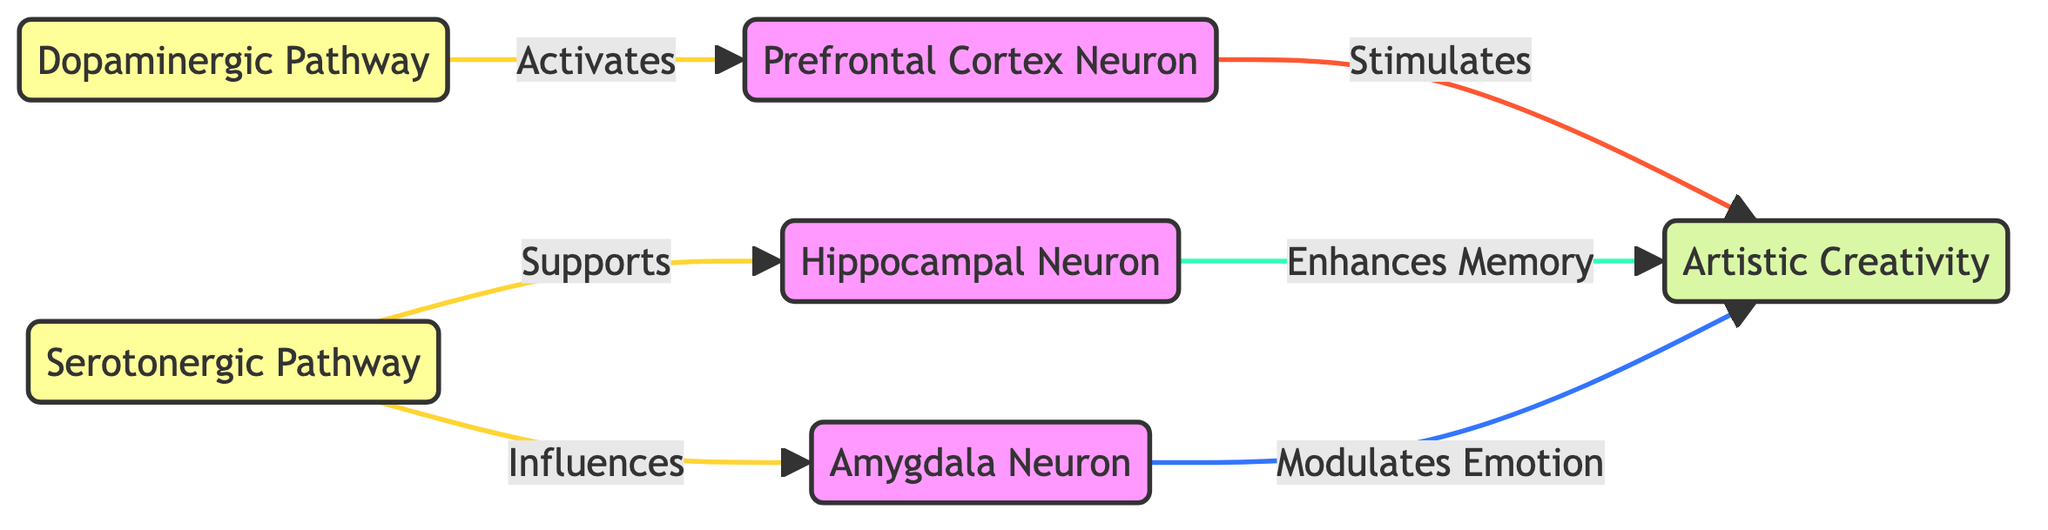What are the three types of neurons represented in the diagram? The diagram identifies three specific types of neurons labeled as "Prefrontal Cortex Neuron," "Hippocampal Neuron," and "Amygdala Neuron."
Answer: Prefrontal Cortex Neuron, Hippocampal Neuron, Amygdala Neuron Which pathway activates the Prefrontal Cortex Neuron? The diagram shows an arrow labeled "Activates," leading from the "Dopaminergic Pathway" to the "Prefrontal Cortex Neuron," indicating its activation role.
Answer: Dopaminergic Pathway How many pathways are illustrated in the diagram? There are two pathways represented in the diagram: "Dopaminergic Pathway" and "Serotonergic Pathway." Counting these gives a total of two pathways.
Answer: 2 What is the primary role of the Hippocampal Neuron regarding artistic creativity? The arrow from "Hippocampal Neuron" to "Artistic Creativity" is labeled "Enhances Memory," indicating its role in supporting creativity through memory enhancement.
Answer: Enhances Memory Which neuron modulates emotion in relation to artistic creativity? The diagram shows an arrow connecting the "Amygdala Neuron" to "Artistic Creativity," labeled "Modulates Emotion," indicating that it plays a role in emotional modulation linked to creativity.
Answer: Amygdala Neuron What color represents the pathways in the diagram? The pathways in the diagram are filled with a yellow color (#ff9), as defined in the diagram's code under the "pathway" class.
Answer: Yellow How does the Dopaminergic Pathway influence creativity? The Dopaminergic Pathway activates the "Prefrontal Cortex Neuron," which then stimulates "Artistic Creativity." Therefore, its influence is direct through activation.
Answer: Stimulates Which neuron is influenced by the Serotonergic Pathway? The "Hippocampal Neuron" is influenced by the "Serotonergic Pathway" according to the arrow labeled "Supports" in the diagram, showing its supportive role.
Answer: Hippocampal Neuron What is the relationship between the Amygdala Neuron and artistic creativity? The "Amygdala Neuron" is shown to connect to "Artistic Creativity," indicated by the arrow labeled "Modulates Emotion," which indicates it affects creativity through emotional modulation.
Answer: Modulates Emotion 